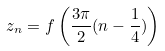<formula> <loc_0><loc_0><loc_500><loc_500>z _ { n } = f \left ( \frac { 3 \pi } { 2 } ( n - \frac { 1 } { 4 } ) \right )</formula> 